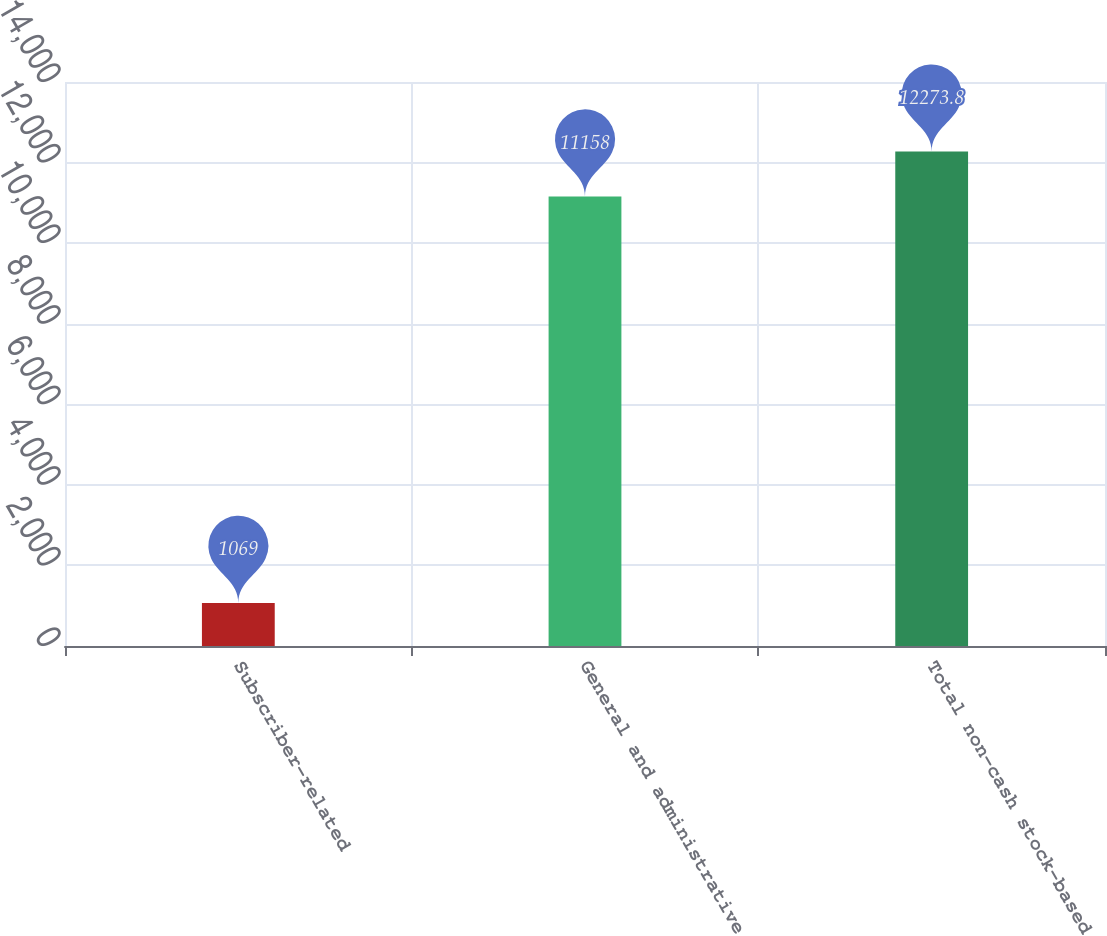Convert chart. <chart><loc_0><loc_0><loc_500><loc_500><bar_chart><fcel>Subscriber-related<fcel>General and administrative<fcel>Total non-cash stock-based<nl><fcel>1069<fcel>11158<fcel>12273.8<nl></chart> 